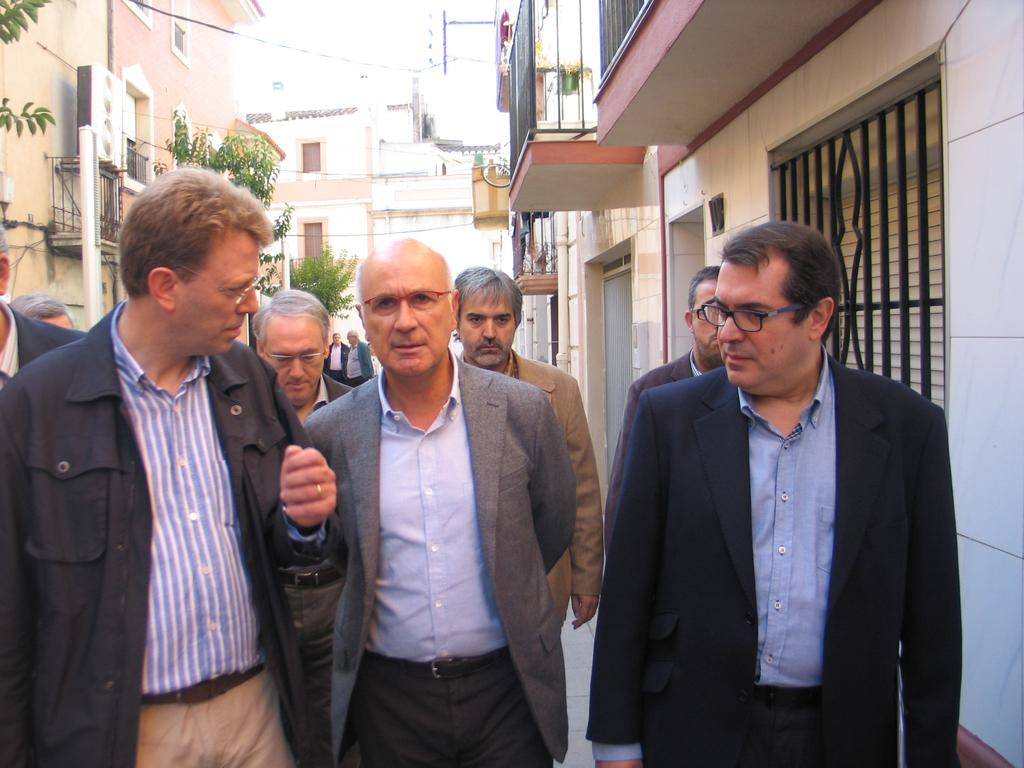What is the main focus of the image? There are people in the center of the image. What can be seen in the distance behind the people? There are buildings in the background of the image. Are there any natural elements present in the image? Yes, there are trees in the image. What type of chain can be seen hanging from the trees in the image? There is no chain present in the image; it only features people, buildings, and trees. Can you tell me how many wishes are granted to the people in the image? There is no mention of wishes or any magical elements in the image; it simply shows people, buildings, and trees. 